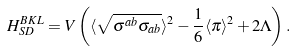<formula> <loc_0><loc_0><loc_500><loc_500>H _ { S D } ^ { B K L } = V \left ( \langle \sqrt { \sigma ^ { a b } \sigma _ { a b } } \rangle ^ { 2 } - \frac { 1 } { 6 } \langle \pi \rangle ^ { 2 } + 2 \Lambda \right ) .</formula> 